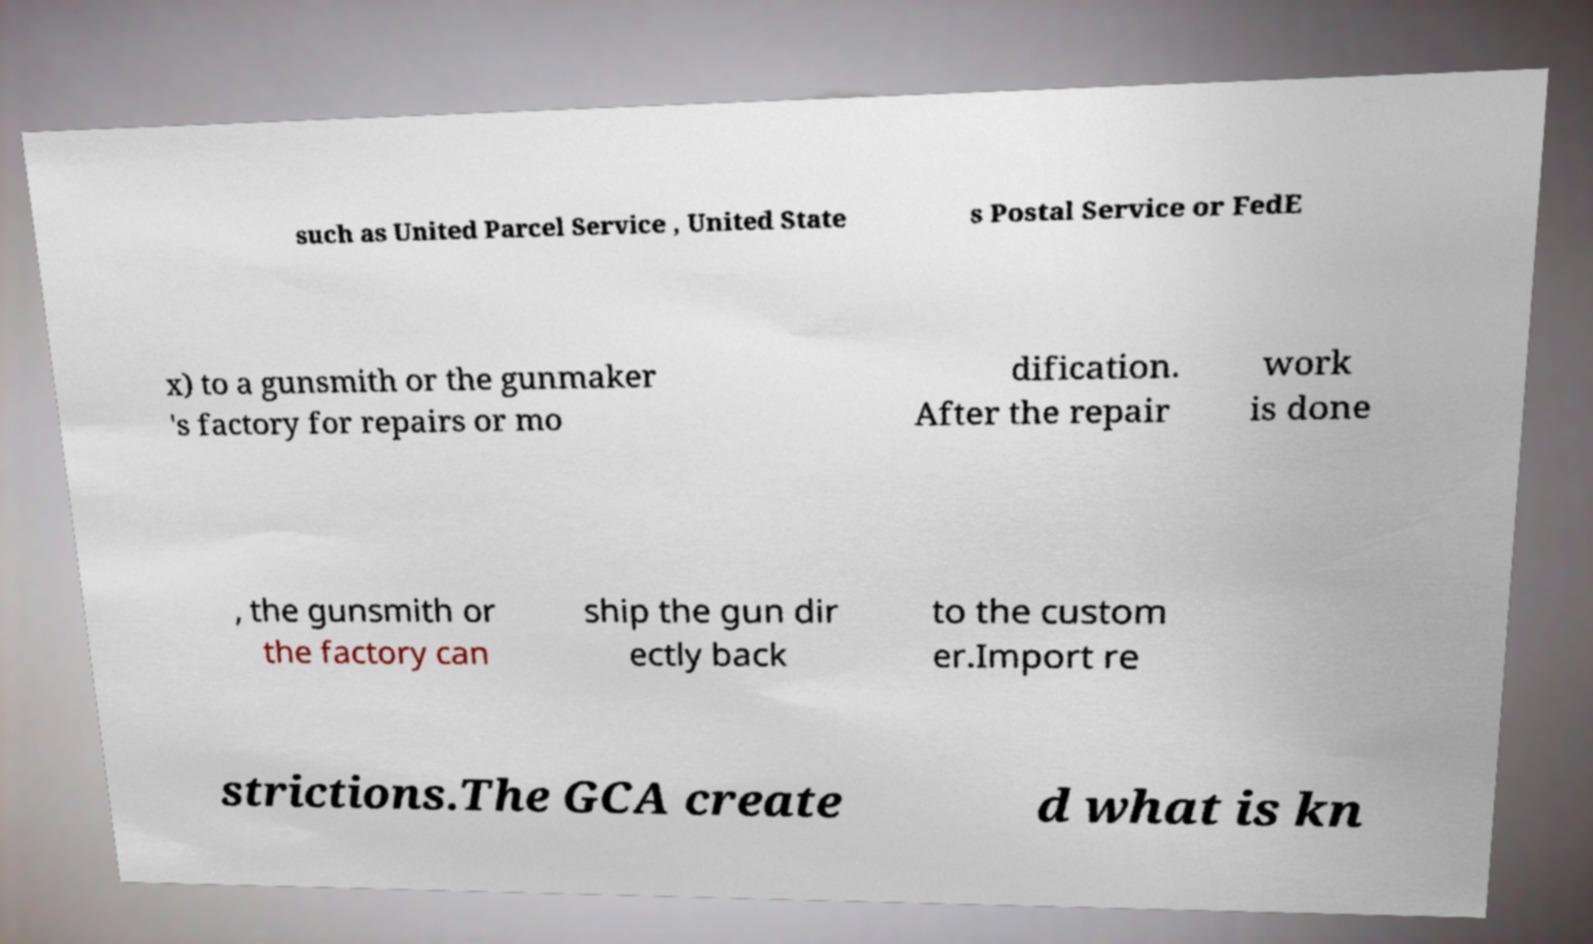What messages or text are displayed in this image? I need them in a readable, typed format. such as United Parcel Service , United State s Postal Service or FedE x) to a gunsmith or the gunmaker 's factory for repairs or mo dification. After the repair work is done , the gunsmith or the factory can ship the gun dir ectly back to the custom er.Import re strictions.The GCA create d what is kn 